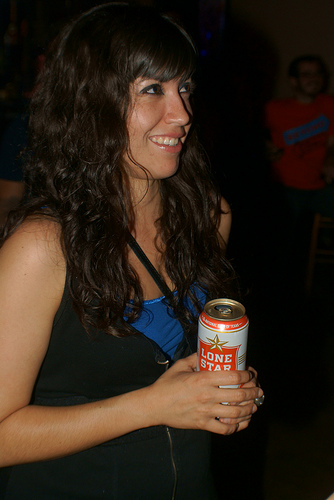<image>
Is the drink in the can? Yes. The drink is contained within or inside the can, showing a containment relationship. 